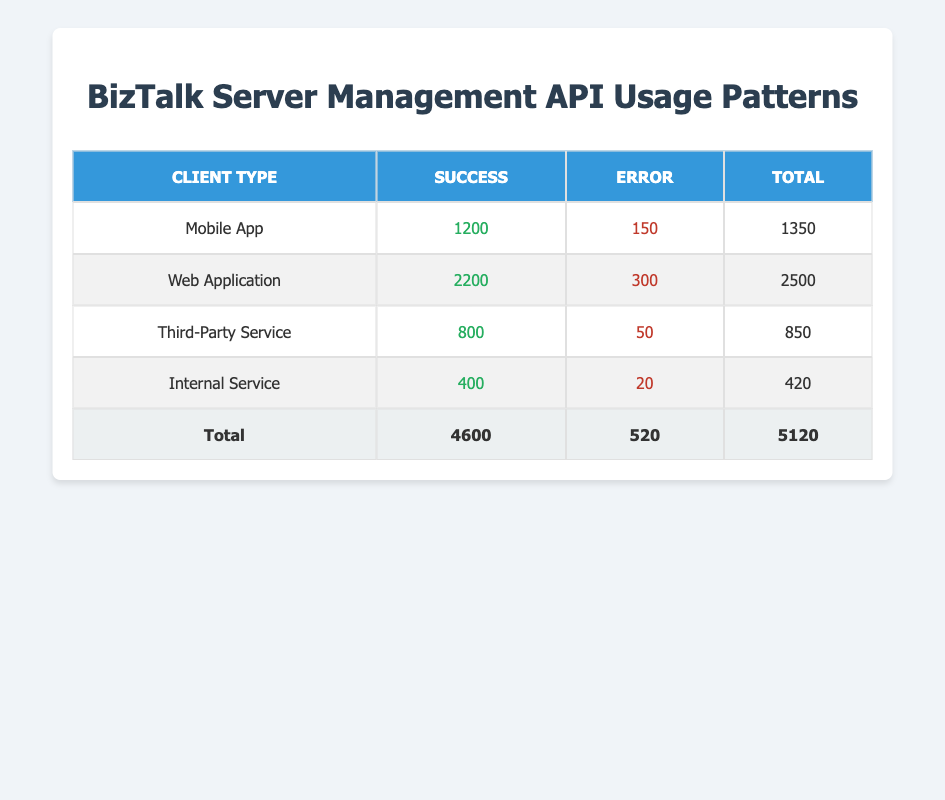What is the total usage count for the Mobile App client type? From the table, the usage count for the Mobile App is listed as 1200 for Success and 150 for Error. Adding these together gives 1200 + 150 = 1350.
Answer: 1350 How many total successful API calls were made by Web Applications? In the table, the Web Application's successful API calls are stated as 2200. So, the total successful calls for this client type is directly 2200.
Answer: 2200 What is the total number of errors reported across all client types? From the table, the total errors for all client types are: Mobile App (150) + Web Application (300) + Third-Party Service (50) + Internal Service (20) = 150 + 300 + 50 + 20 = 520.
Answer: 520 Did Third-Party Services have more successful calls than Internal Services? The table shows Third-Party Services had 800 successful calls while Internal Services had 400. Since 800 is greater than 400, the statement is true.
Answer: Yes What is the average usage count (total calls) per client type? To find the average, we first add up all the total usage counts: 1350 (Mobile App) + 2500 (Web Application) + 850 (Third-Party) + 420 (Internal) = 5120. There are 4 client types, hence the average is 5120 / 4 = 1280.
Answer: 1280 Which client type had the least number of error calls? Looking at the Error column, we see the counts: Mobile App (150), Web Application (300), Third-Party Service (50), Internal Service (20). The least number is for Internal Service with 20 errors.
Answer: Internal Service What percentage of total API calls were errors? Total API calls are found by adding all successful and error calls: 4600 (Success) + 520 (Error) = 5120. The errors account for 520 out of 5120, so the percentage is (520 / 5120) * 100 = 10.16%.
Answer: Approximately 10.16% How many more successful calls did Web Applications have compared to Third-Party Services? Web Applications have 2200 successful calls, while Third-Party Services have 800. The difference is 2200 - 800 = 1400.
Answer: 1400 Was the total usage count for Internal Services less than that of Mobile Apps? The total usage count for Internal Services is 420, and for Mobile Apps it is 1350. Since 420 is less than 1350, the statement is true.
Answer: Yes 